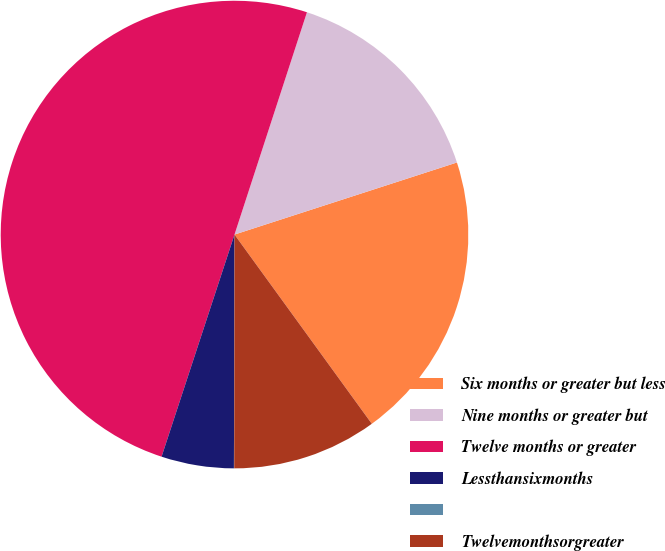Convert chart to OTSL. <chart><loc_0><loc_0><loc_500><loc_500><pie_chart><fcel>Six months or greater but less<fcel>Nine months or greater but<fcel>Twelve months or greater<fcel>Lessthansixmonths<fcel>Unnamed: 4<fcel>Twelvemonthsorgreater<nl><fcel>20.0%<fcel>15.0%<fcel>49.97%<fcel>5.01%<fcel>0.02%<fcel>10.01%<nl></chart> 